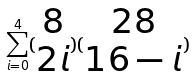<formula> <loc_0><loc_0><loc_500><loc_500>\sum _ { i = 0 } ^ { 4 } ( \begin{matrix} 8 \\ 2 i \end{matrix} ) ( \begin{matrix} 2 8 \\ 1 6 - i \end{matrix} )</formula> 